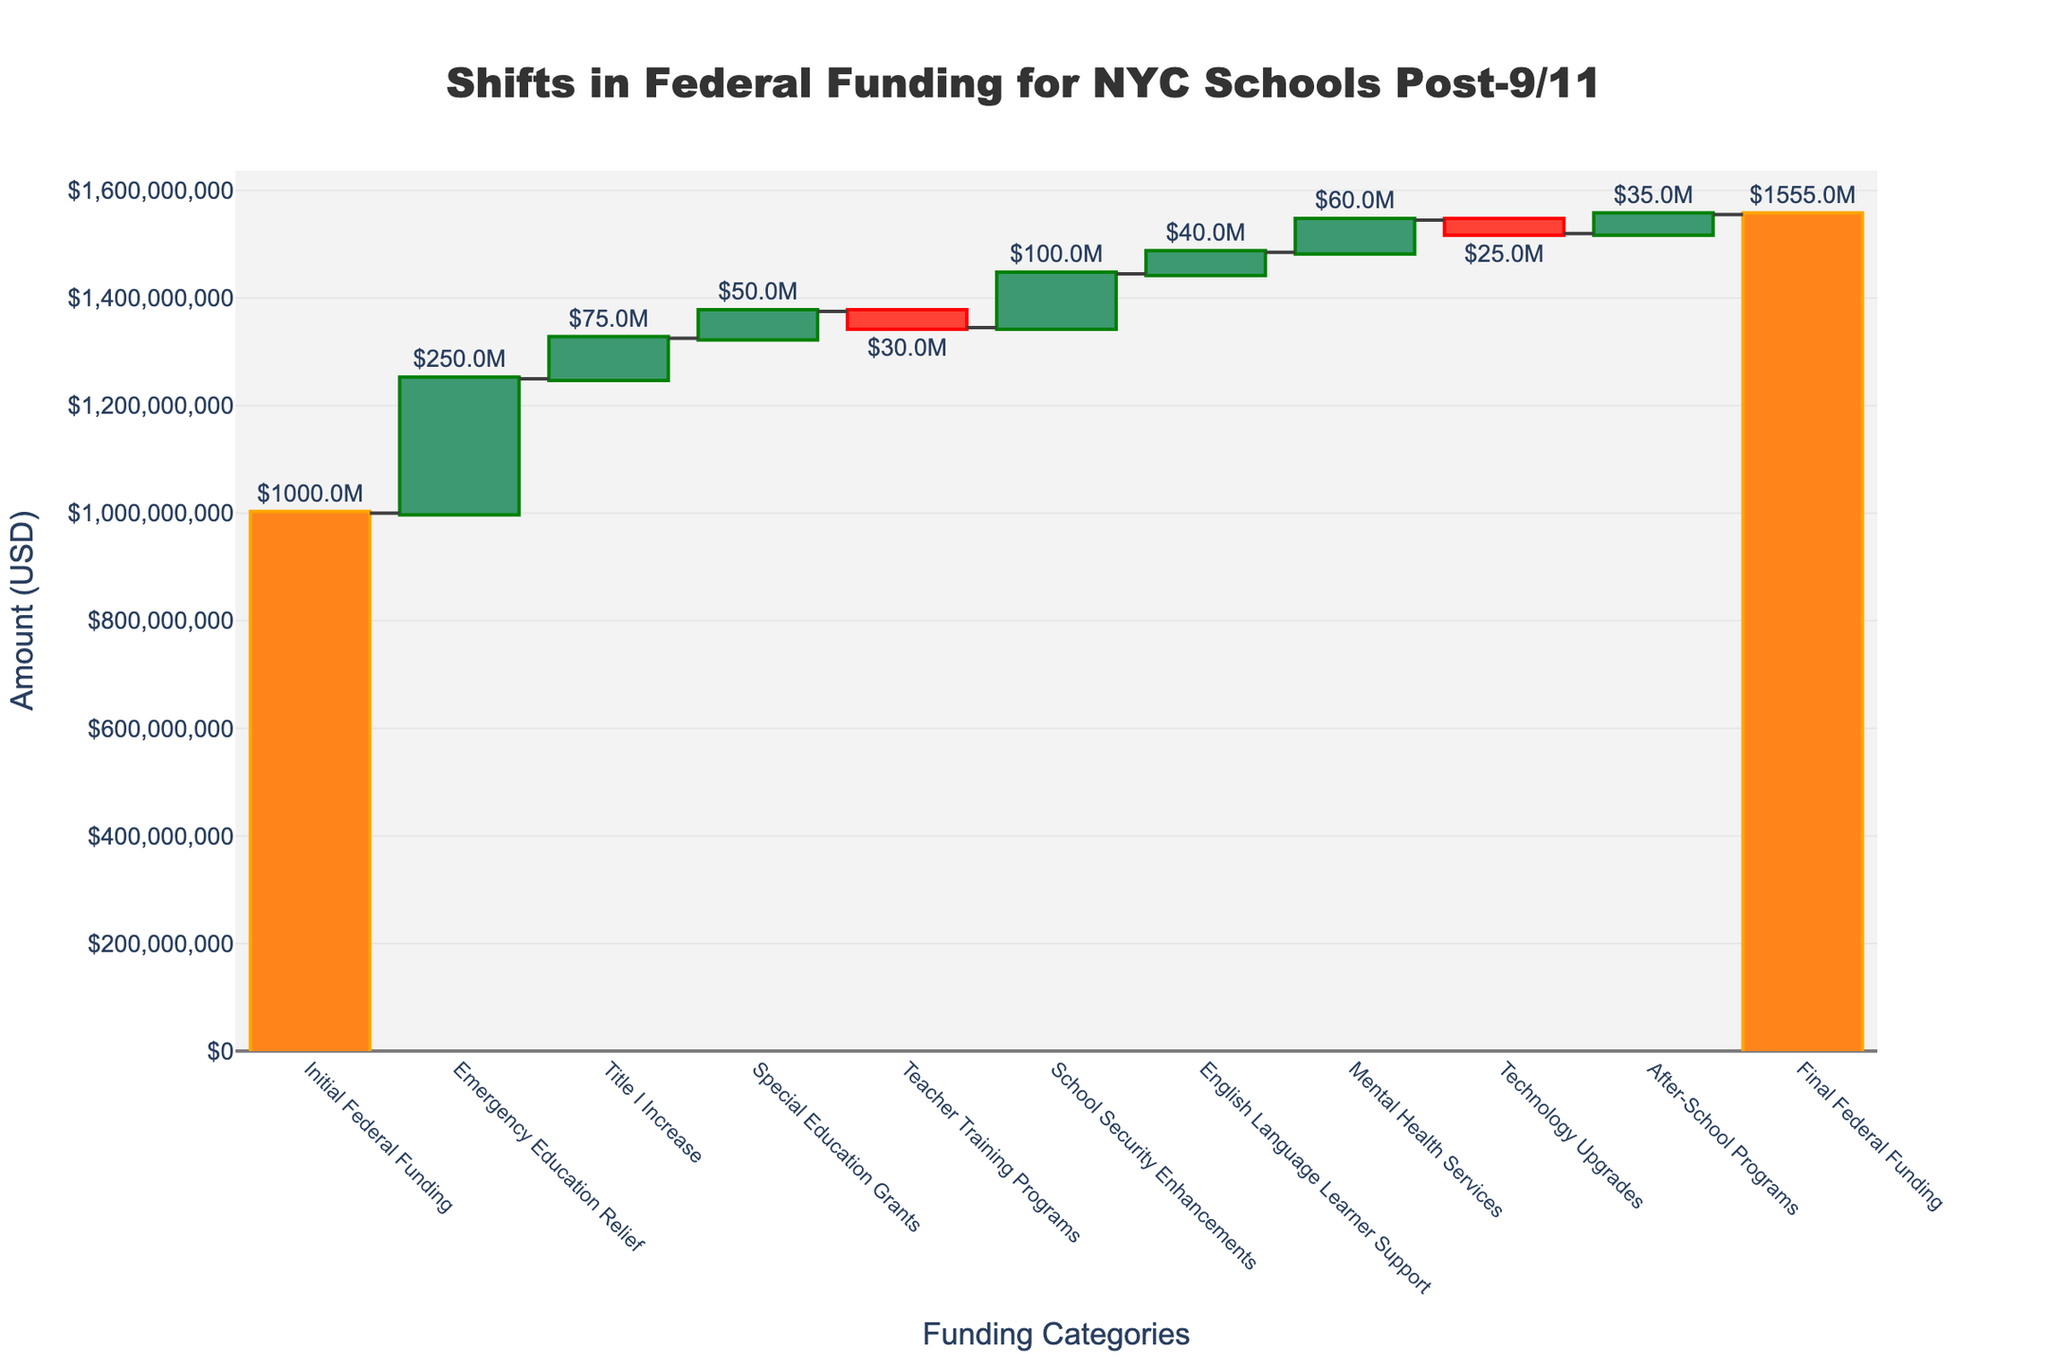What's the initial federal funding amount allocated to New York City public schools? The initial funding amount is directly shown as the first bar in the waterfall chart. The value label on this bar reads $1.0B, which means one billion dollars.
Answer: $1.0B What's the total increase in funding from Emergency Education Relief and Special Education Grants combined? The values for Emergency Education Relief and Special Education Grants are $250M and $50M respectively. Summing these values gives $250M + $50M = $300M.
Answer: $300M By how much did Title I funding increase? Referring to the bar for Title I Increase in the waterfall chart, the value label indicates an increase of $75M.
Answer: $75M Which category saw a decrease in funding for Teacher Training Programs and how much was it? The bar for Teacher Training Programs is shown decreasing (in a downward direction), and the value label reads $-30M.
Answer: $-30M How does the final federal funding compare to the initial federal funding? The initial federal funding is $1.0B, and the final federal funding is $1.555B. The difference between the two values can be calculated as $1.555B - $1.0B = $555M.
Answer: $555M What is the net change in funding due to Technology Upgrades and After-School Programs combined? The value for Technology Upgrades is $-25M, and After-School Programs is $35M. The net change is calculated as $-25M + $35M = $10M.
Answer: $10M Which category contributed the most to the increase in funding? By comparing the positive increments in the waterfall chart, Emergency Education Relief has the highest value of $250M, which is the largest increase among the categories.
Answer: Emergency Education Relief What is the total funding increase (excluding decreases) from all the categories other than the initial and the final funding amounts? Summing up the positive values from the relevant categories: $250M (Emergency Education Relief) + $75M (Title I Increase) + $50M (Special Education Grants) + $100M (School Security Enhancements) + $40M (English Language Learner Support) + $60M (Mental Health Services) + $35M (After-School Programs) = $610M.
Answer: $610M What categories led to a reduction in federal funding allocation? The categories that show a decrease are Teacher Training Programs and Technology Upgrades, with values $-30M and $-25M, respectively.
Answer: Teacher Training Programs, Technology Upgrades 